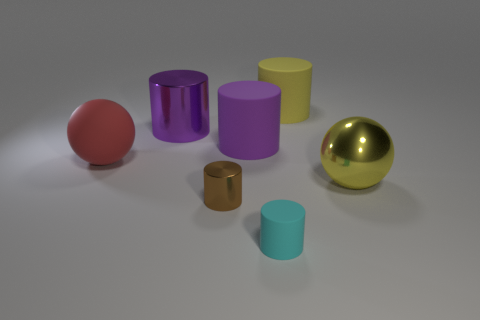What is the small brown thing made of? The small brown item appears to be a miniature cylinder with a reflective surface, suggesting that it could be made of a polished metal or a metal-like material. 